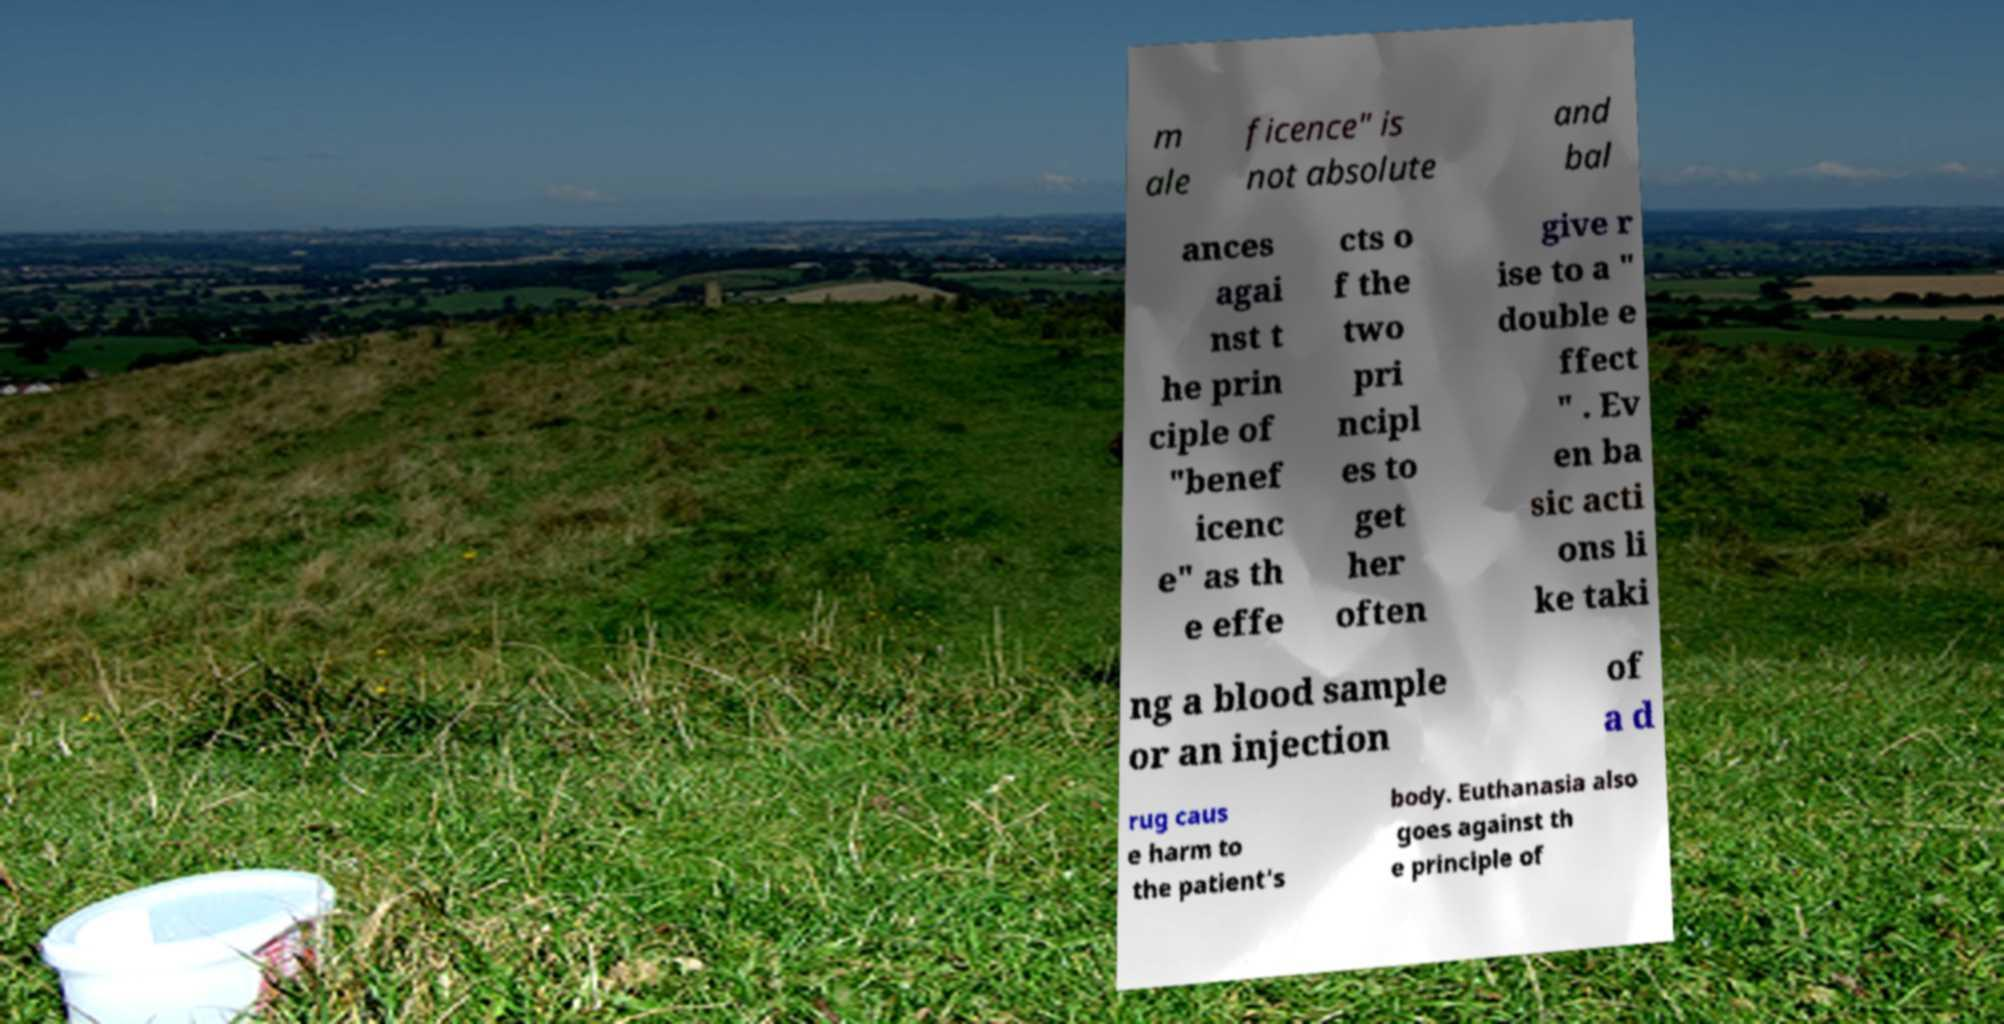What messages or text are displayed in this image? I need them in a readable, typed format. m ale ficence" is not absolute and bal ances agai nst t he prin ciple of "benef icenc e" as th e effe cts o f the two pri ncipl es to get her often give r ise to a " double e ffect " . Ev en ba sic acti ons li ke taki ng a blood sample or an injection of a d rug caus e harm to the patient's body. Euthanasia also goes against th e principle of 